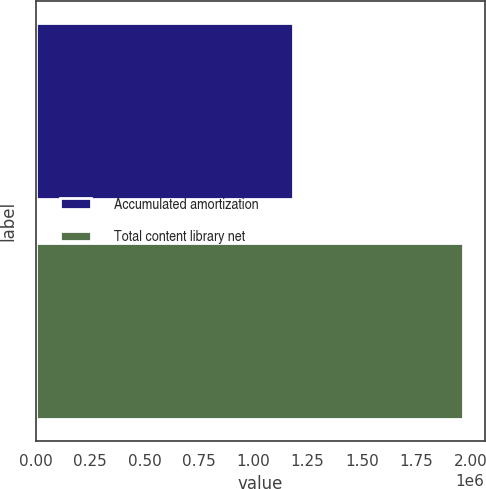Convert chart. <chart><loc_0><loc_0><loc_500><loc_500><bar_chart><fcel>Accumulated amortization<fcel>Total content library net<nl><fcel>1.1848e+06<fcel>1.96664e+06<nl></chart> 